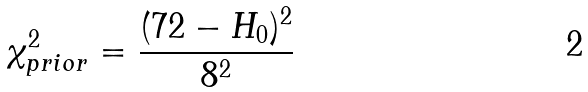Convert formula to latex. <formula><loc_0><loc_0><loc_500><loc_500>\chi ^ { 2 } _ { p r i o r } = \frac { ( 7 2 - H _ { 0 } ) ^ { 2 } } { 8 ^ { 2 } }</formula> 